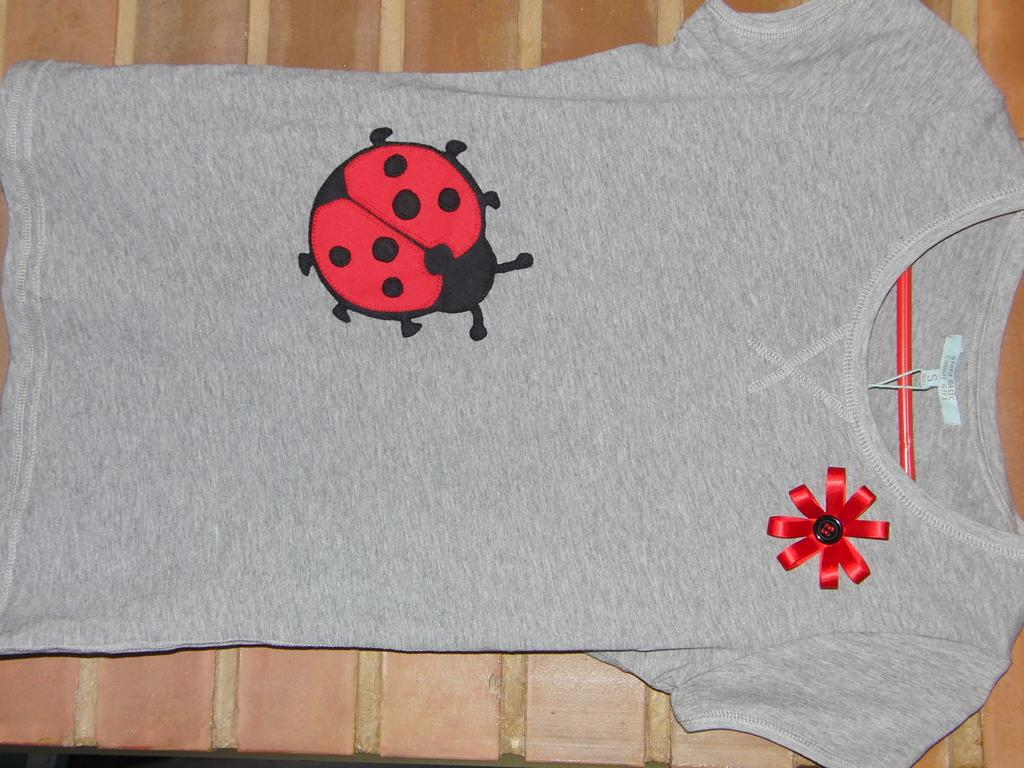What item is visible in the image? There is a t-shirt in the image. Where is the t-shirt located? The t-shirt is placed on a table. What design is featured on the t-shirt? The t-shirt has a design of an inset. How many yards of wax were used to create the design on the t-shirt? There is no mention of wax or yardage in the image, as the design is an inset and not made of wax. 